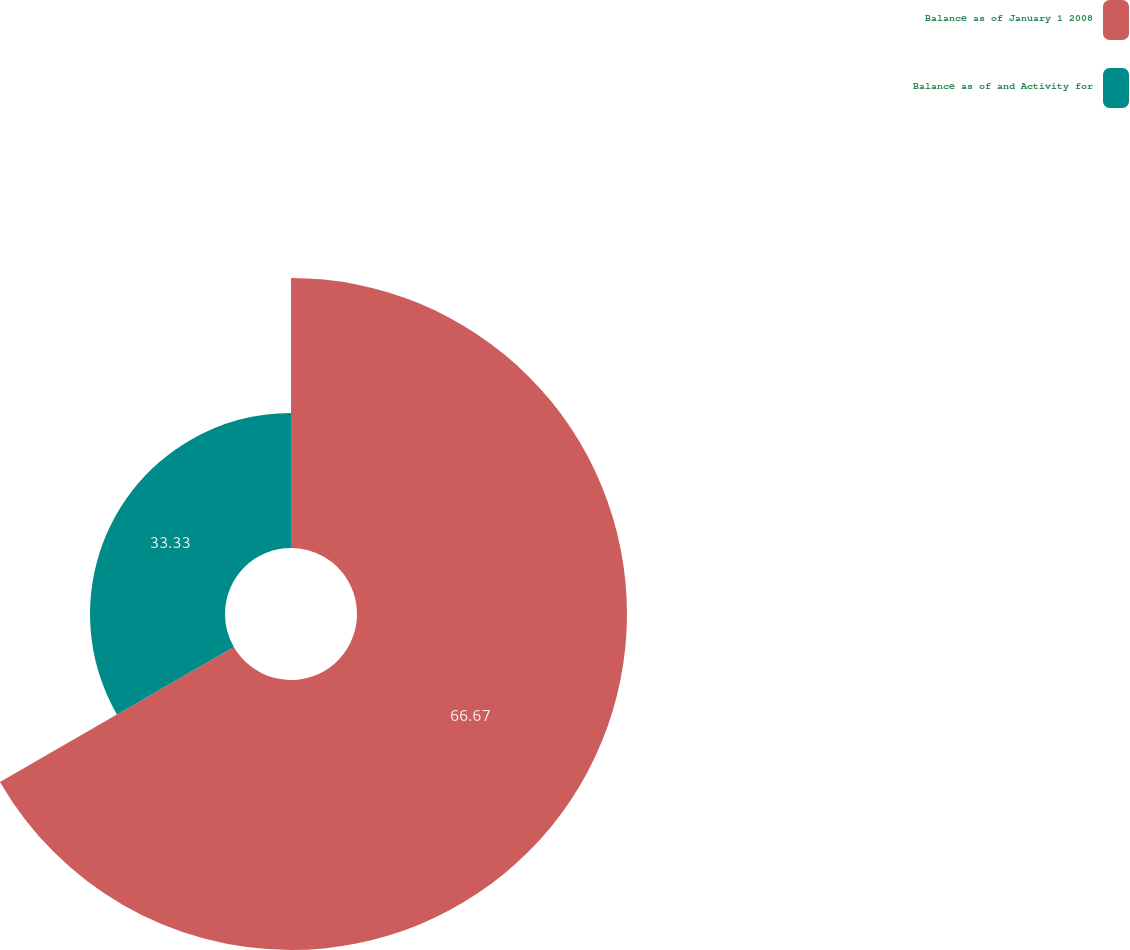Convert chart to OTSL. <chart><loc_0><loc_0><loc_500><loc_500><pie_chart><fcel>Balance as of January 1 2008<fcel>Balance as of and Activity for<nl><fcel>66.67%<fcel>33.33%<nl></chart> 